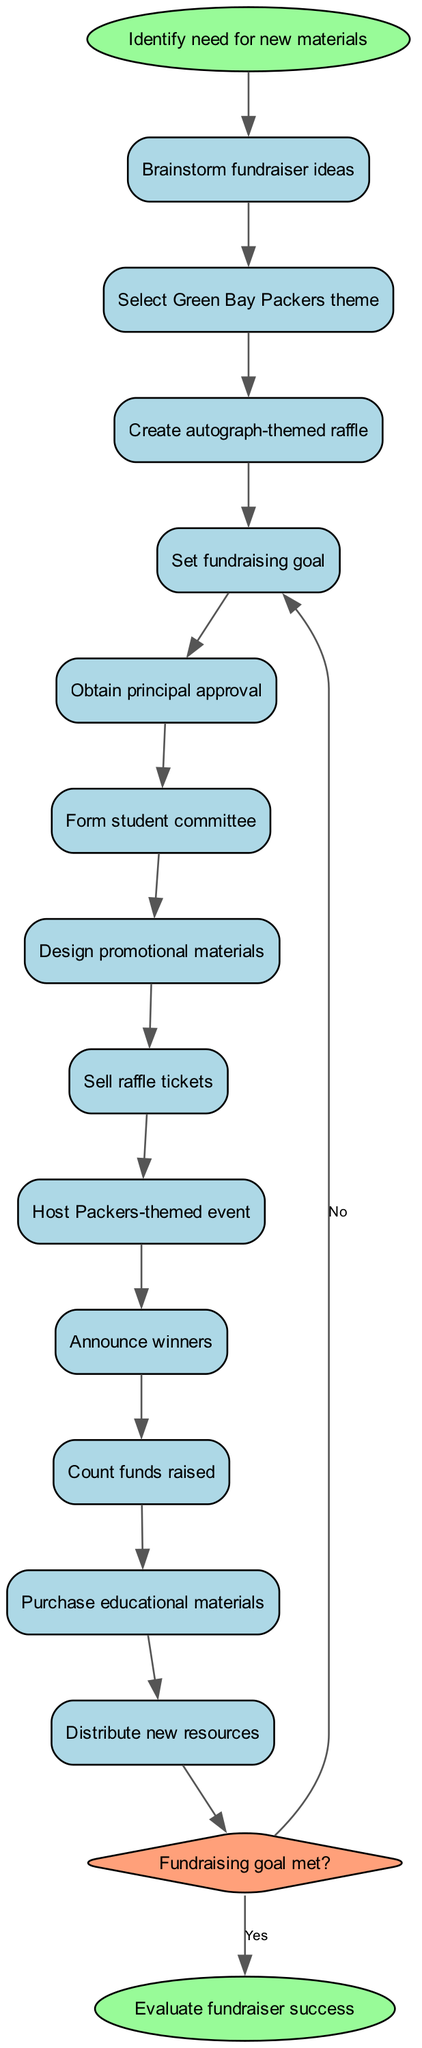What is the starting point of the diagram? The starting point of the diagram is indicated by the node labeled "Identify need for new materials." It is the first node from which other steps branch out.
Answer: Identify need for new materials How many total steps are there in the process? There are 12 steps listed in the diagram, which follow a sequential flow from brainstorming ideas to distributing new resources.
Answer: 12 What is the last step before the decision node? The last step before the decision node is "Count funds raised." This indicates that it occurs immediately before evaluating if the fundraising goal was met.
Answer: Count funds raised What happens if the fundraising goal is not met? If the fundraising goal is not met, the flow returns to "Set fundraising goal" according to the loop shown in the diagram. This implies that the process repeats to ensure the goal is achieved.
Answer: Set fundraising goal What is the theme selected for the fundraiser? The theme selected for the fundraiser, as indicated in the diagram, is "Green Bay Packers theme." This sets the cultural context for the fundraising activities.
Answer: Green Bay Packers theme What action follows the announcement of winners? After the announcement of winners, the next action is "Count funds raised," which measures the total money collected from the fundraising efforts.
Answer: Count funds raised What color represents the decision node? The decision node is represented in light orange, specifically with the color code #FFA07A, visually distinguishing it from other steps.
Answer: #FFA07A What is evaluated at the end of the process? The final evaluation done at the end of the process is "Evaluate fundraiser success," summarizing the overall effectiveness of the fundraising activities carried out.
Answer: Evaluate fundraiser success 